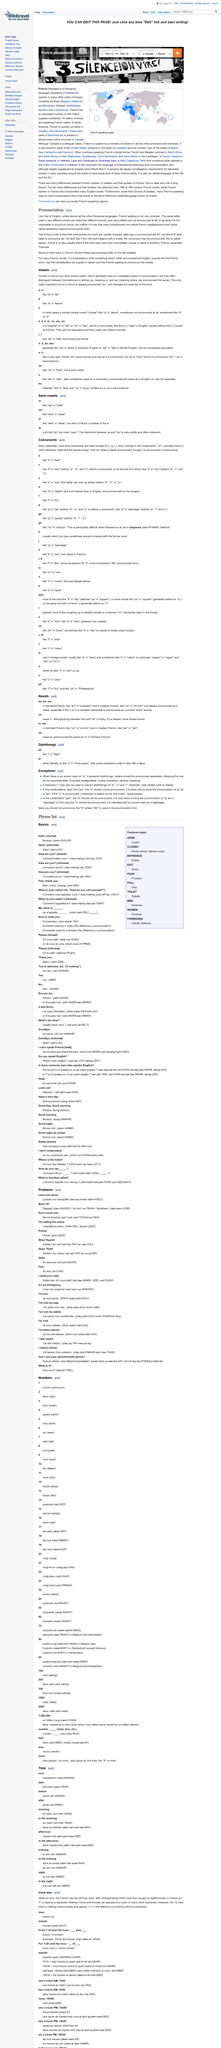Point out several critical features in this image. It is possible in French pronunciation for the same letter to produce different sounds in different words. The act of pronouncing a consonant when the next word begins with a vowel is called liaison. The mispronunciation of words is not limited to non-native French speakers, as even some native speakers occasionally make errors in their pronunciation. 